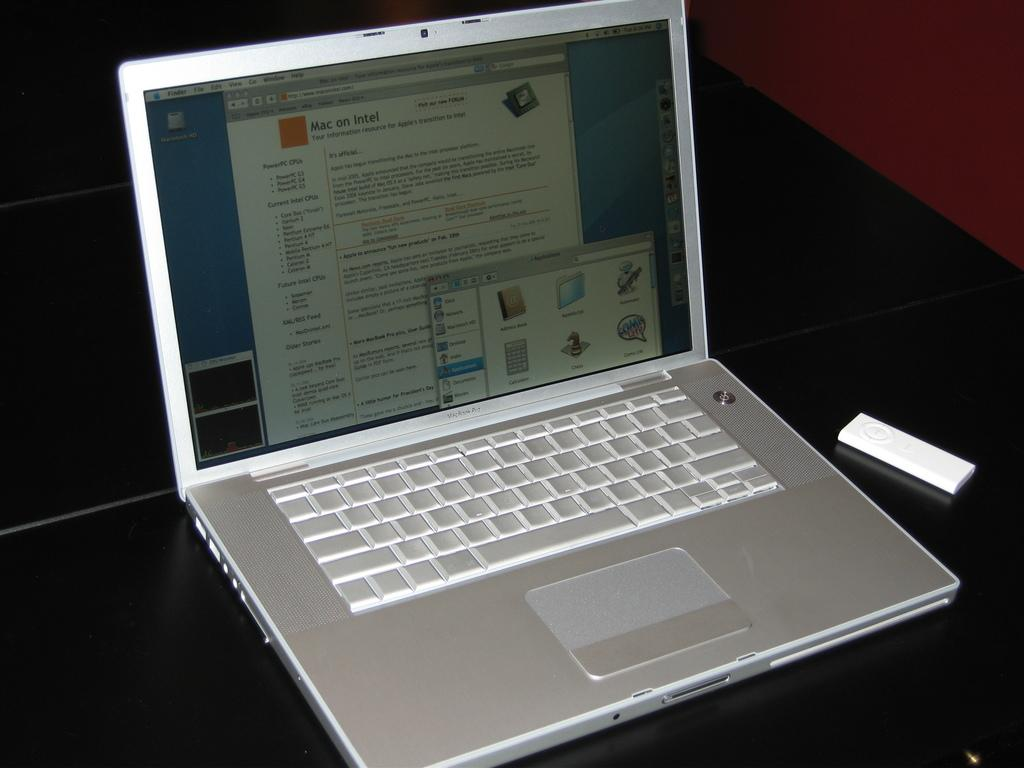<image>
Share a concise interpretation of the image provided. Silver Macbook Pro showing a screen that says Mac on Intel. 